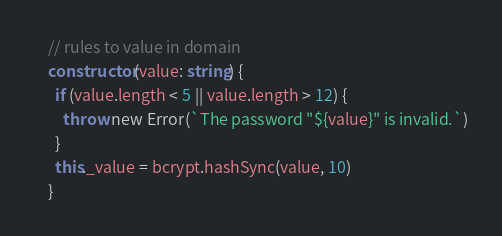Convert code to text. <code><loc_0><loc_0><loc_500><loc_500><_TypeScript_>
    // rules to value in domain
    constructor(value: string) {
      if (value.length < 5 || value.length > 12) {
        throw new Error(`The password "${value}" is invalid.`)
      }
      this._value = bcrypt.hashSync(value, 10)
    }
</code> 